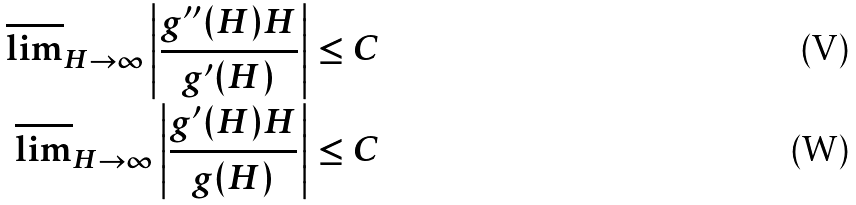<formula> <loc_0><loc_0><loc_500><loc_500>\overline { \lim } _ { H \rightarrow \infty } \left | \frac { g ^ { \prime \prime } ( H ) H } { g ^ { \prime } ( H ) } \right | \leq C \\ \overline { \lim } _ { H \rightarrow \infty } \left | \frac { g ^ { \prime } ( H ) H } { g ( H ) } \right | \leq C</formula> 